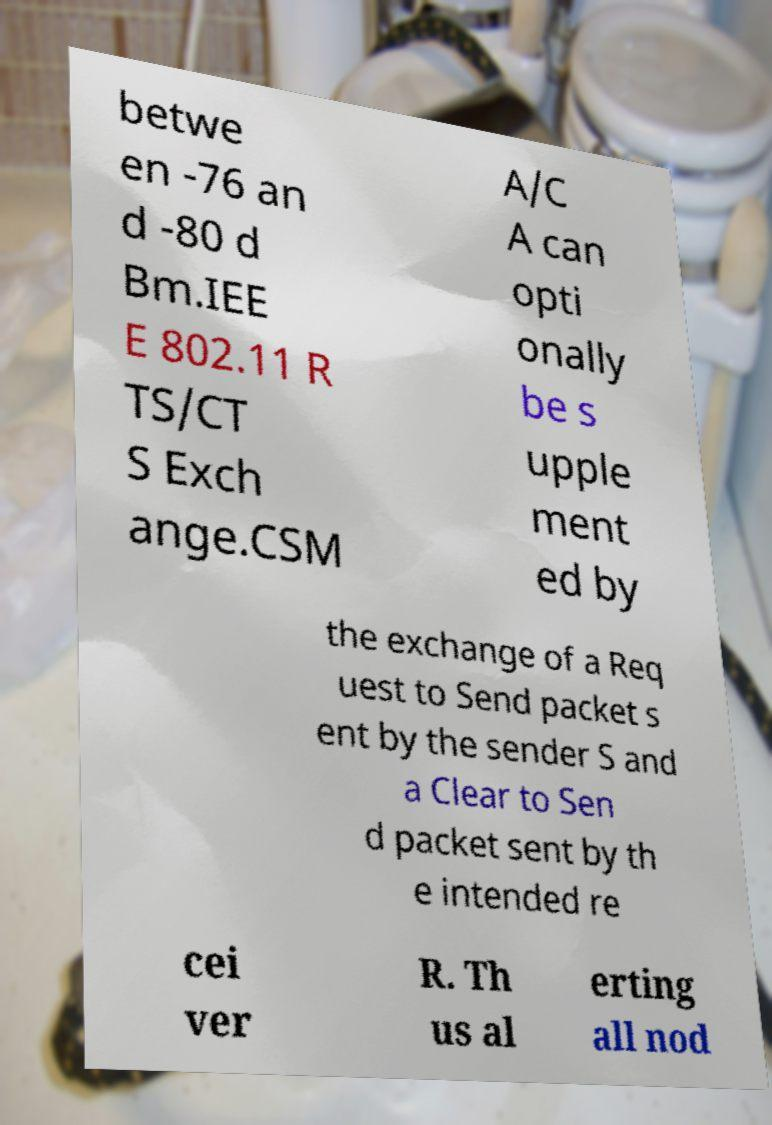Can you read and provide the text displayed in the image?This photo seems to have some interesting text. Can you extract and type it out for me? betwe en -76 an d -80 d Bm.IEE E 802.11 R TS/CT S Exch ange.CSM A/C A can opti onally be s upple ment ed by the exchange of a Req uest to Send packet s ent by the sender S and a Clear to Sen d packet sent by th e intended re cei ver R. Th us al erting all nod 